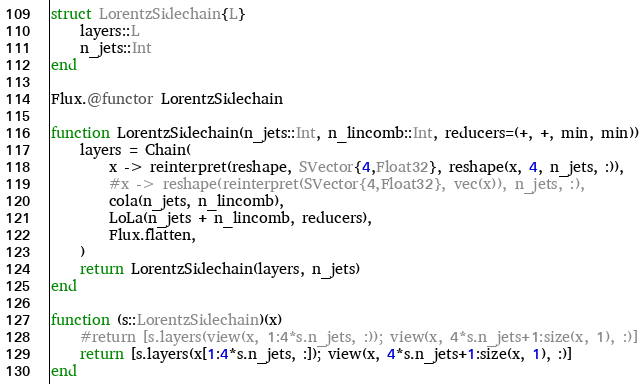Convert code to text. <code><loc_0><loc_0><loc_500><loc_500><_Julia_>struct LorentzSidechain{L}
    layers::L
    n_jets::Int
end

Flux.@functor LorentzSidechain

function LorentzSidechain(n_jets::Int, n_lincomb::Int, reducers=(+, +, min, min))
    layers = Chain(
        x -> reinterpret(reshape, SVector{4,Float32}, reshape(x, 4, n_jets, :)),
        #x -> reshape(reinterpret(SVector{4,Float32}, vec(x)), n_jets, :),
        cola(n_jets, n_lincomb),
        LoLa(n_jets + n_lincomb, reducers),
        Flux.flatten,
    )
    return LorentzSidechain(layers, n_jets)
end

function (s::LorentzSidechain)(x)
    #return [s.layers(view(x, 1:4*s.n_jets, :)); view(x, 4*s.n_jets+1:size(x, 1), :)]
    return [s.layers(x[1:4*s.n_jets, :]); view(x, 4*s.n_jets+1:size(x, 1), :)]
end
</code> 